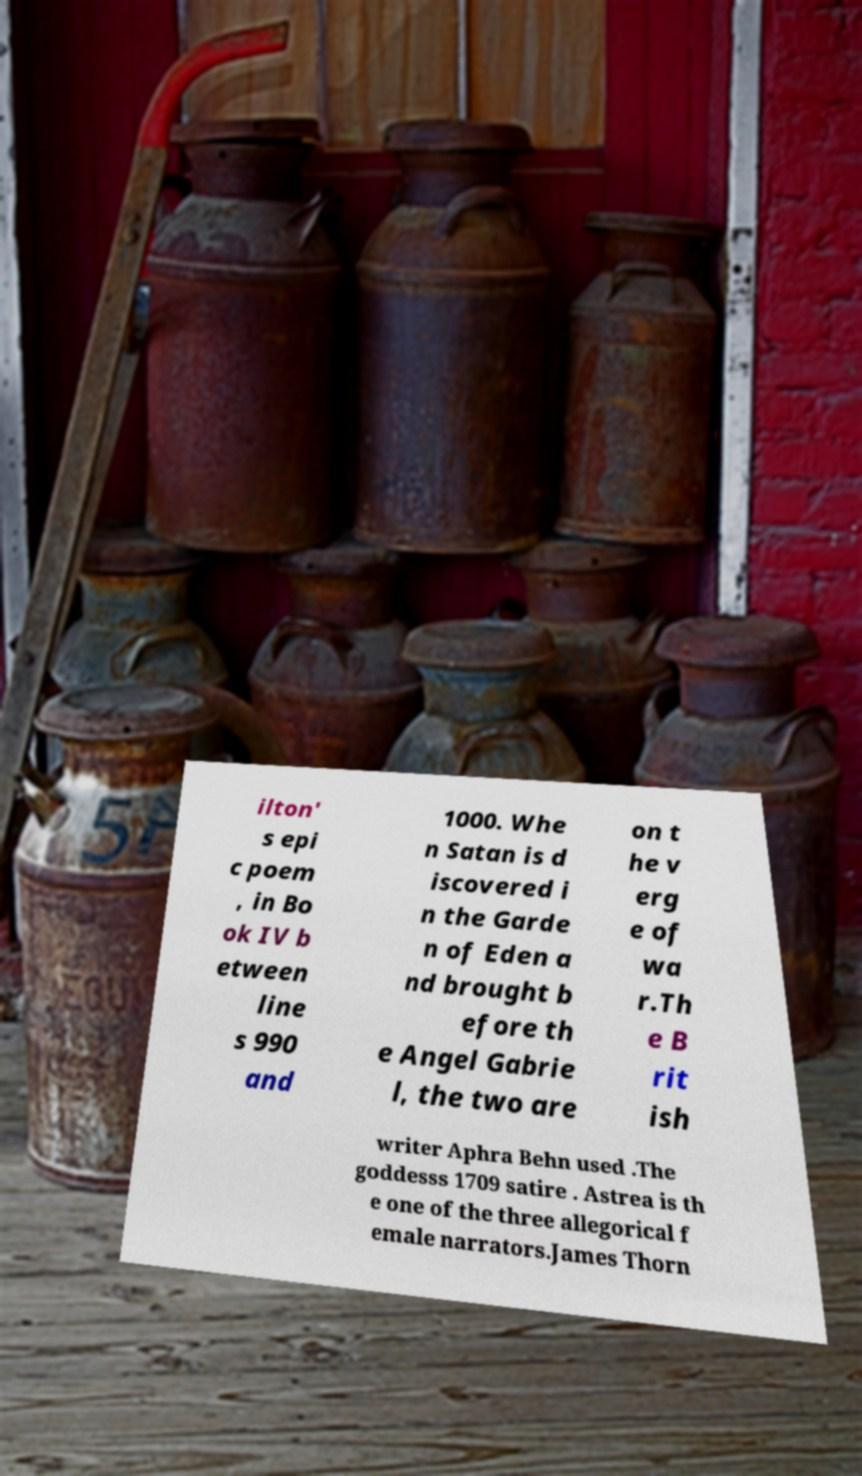Please identify and transcribe the text found in this image. ilton' s epi c poem , in Bo ok IV b etween line s 990 and 1000. Whe n Satan is d iscovered i n the Garde n of Eden a nd brought b efore th e Angel Gabrie l, the two are on t he v erg e of wa r.Th e B rit ish writer Aphra Behn used .The goddesss 1709 satire . Astrea is th e one of the three allegorical f emale narrators.James Thorn 